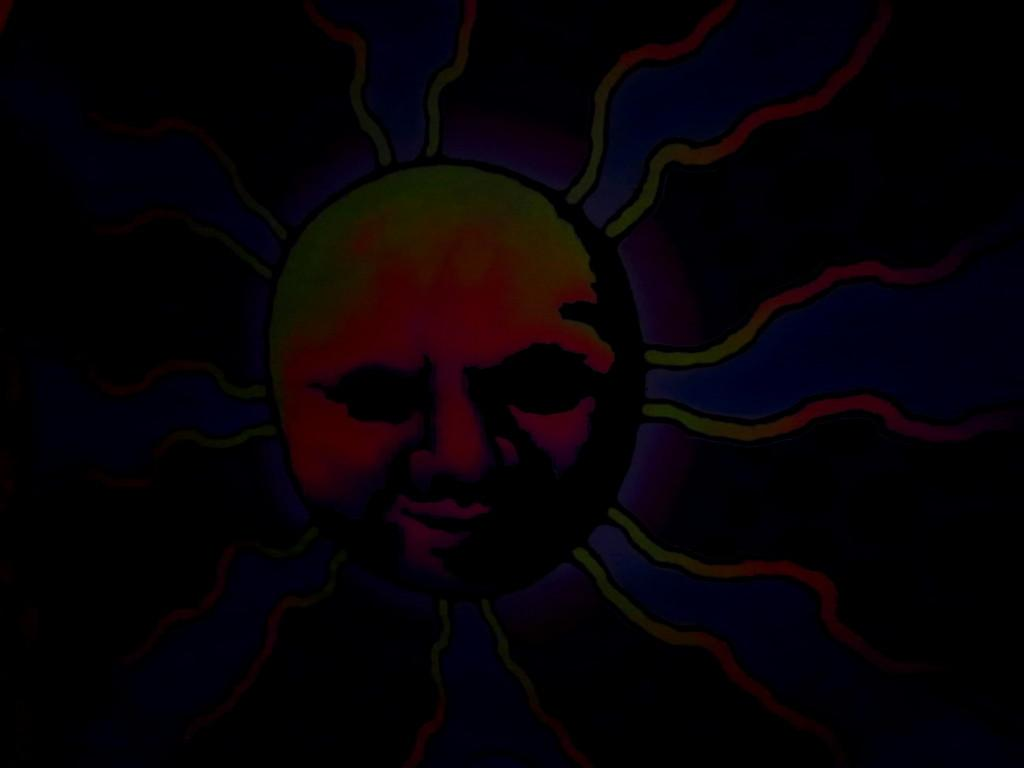What is the main subject of the image? The main subject of the image is a painting. What does the painting depict? The painting depicts a person's face. What type of shoe is being worn by the person in the painting? There is no shoe visible in the painting, as it only depicts a person's face. What emotion is the person's heart expressing in the painting? There is no heart visible in the painting, as it only depicts a person's face. 